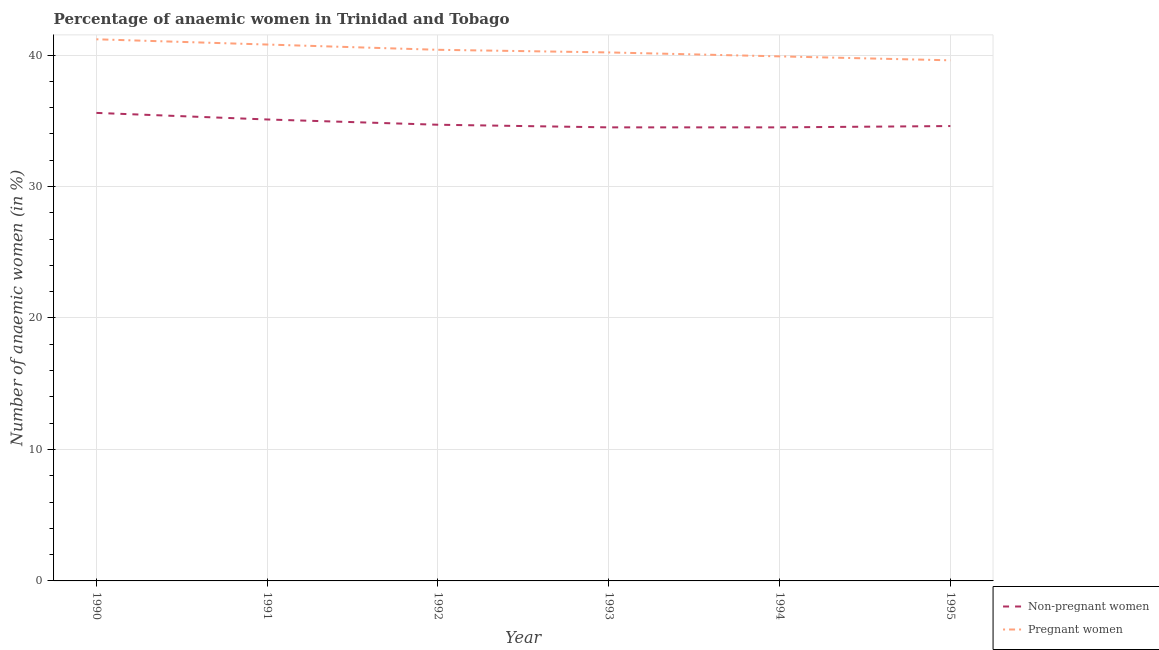Is the number of lines equal to the number of legend labels?
Offer a very short reply. Yes. What is the percentage of pregnant anaemic women in 1995?
Provide a short and direct response. 39.6. Across all years, what is the maximum percentage of pregnant anaemic women?
Give a very brief answer. 41.2. Across all years, what is the minimum percentage of pregnant anaemic women?
Provide a succinct answer. 39.6. In which year was the percentage of non-pregnant anaemic women maximum?
Offer a very short reply. 1990. In which year was the percentage of pregnant anaemic women minimum?
Your answer should be very brief. 1995. What is the total percentage of non-pregnant anaemic women in the graph?
Your answer should be compact. 209. What is the difference between the percentage of non-pregnant anaemic women in 1992 and that in 1995?
Your answer should be compact. 0.1. What is the difference between the percentage of non-pregnant anaemic women in 1993 and the percentage of pregnant anaemic women in 1994?
Ensure brevity in your answer.  -5.4. What is the average percentage of pregnant anaemic women per year?
Offer a terse response. 40.35. In the year 1990, what is the difference between the percentage of pregnant anaemic women and percentage of non-pregnant anaemic women?
Your answer should be compact. 5.6. In how many years, is the percentage of non-pregnant anaemic women greater than 16 %?
Offer a terse response. 6. What is the ratio of the percentage of non-pregnant anaemic women in 1990 to that in 1992?
Provide a short and direct response. 1.03. Is the percentage of pregnant anaemic women in 1990 less than that in 1993?
Give a very brief answer. No. What is the difference between the highest and the lowest percentage of pregnant anaemic women?
Provide a succinct answer. 1.6. Is the sum of the percentage of pregnant anaemic women in 1990 and 1994 greater than the maximum percentage of non-pregnant anaemic women across all years?
Ensure brevity in your answer.  Yes. Is the percentage of pregnant anaemic women strictly greater than the percentage of non-pregnant anaemic women over the years?
Offer a terse response. Yes. How many lines are there?
Your answer should be compact. 2. How many years are there in the graph?
Your answer should be compact. 6. What is the difference between two consecutive major ticks on the Y-axis?
Your answer should be compact. 10. Does the graph contain any zero values?
Offer a very short reply. No. Where does the legend appear in the graph?
Your answer should be compact. Bottom right. How are the legend labels stacked?
Give a very brief answer. Vertical. What is the title of the graph?
Ensure brevity in your answer.  Percentage of anaemic women in Trinidad and Tobago. Does "Highest 10% of population" appear as one of the legend labels in the graph?
Provide a short and direct response. No. What is the label or title of the X-axis?
Your response must be concise. Year. What is the label or title of the Y-axis?
Offer a terse response. Number of anaemic women (in %). What is the Number of anaemic women (in %) of Non-pregnant women in 1990?
Make the answer very short. 35.6. What is the Number of anaemic women (in %) in Pregnant women in 1990?
Offer a very short reply. 41.2. What is the Number of anaemic women (in %) in Non-pregnant women in 1991?
Provide a short and direct response. 35.1. What is the Number of anaemic women (in %) in Pregnant women in 1991?
Give a very brief answer. 40.8. What is the Number of anaemic women (in %) of Non-pregnant women in 1992?
Your answer should be very brief. 34.7. What is the Number of anaemic women (in %) in Pregnant women in 1992?
Provide a short and direct response. 40.4. What is the Number of anaemic women (in %) of Non-pregnant women in 1993?
Your response must be concise. 34.5. What is the Number of anaemic women (in %) of Pregnant women in 1993?
Your answer should be compact. 40.2. What is the Number of anaemic women (in %) of Non-pregnant women in 1994?
Your answer should be compact. 34.5. What is the Number of anaemic women (in %) in Pregnant women in 1994?
Your response must be concise. 39.9. What is the Number of anaemic women (in %) of Non-pregnant women in 1995?
Your answer should be very brief. 34.6. What is the Number of anaemic women (in %) in Pregnant women in 1995?
Give a very brief answer. 39.6. Across all years, what is the maximum Number of anaemic women (in %) of Non-pregnant women?
Give a very brief answer. 35.6. Across all years, what is the maximum Number of anaemic women (in %) of Pregnant women?
Offer a very short reply. 41.2. Across all years, what is the minimum Number of anaemic women (in %) in Non-pregnant women?
Ensure brevity in your answer.  34.5. Across all years, what is the minimum Number of anaemic women (in %) in Pregnant women?
Offer a terse response. 39.6. What is the total Number of anaemic women (in %) of Non-pregnant women in the graph?
Provide a short and direct response. 209. What is the total Number of anaemic women (in %) of Pregnant women in the graph?
Provide a succinct answer. 242.1. What is the difference between the Number of anaemic women (in %) in Pregnant women in 1990 and that in 1991?
Keep it short and to the point. 0.4. What is the difference between the Number of anaemic women (in %) of Non-pregnant women in 1990 and that in 1992?
Provide a succinct answer. 0.9. What is the difference between the Number of anaemic women (in %) of Pregnant women in 1990 and that in 1992?
Provide a succinct answer. 0.8. What is the difference between the Number of anaemic women (in %) of Non-pregnant women in 1990 and that in 1993?
Your response must be concise. 1.1. What is the difference between the Number of anaemic women (in %) of Pregnant women in 1990 and that in 1993?
Offer a very short reply. 1. What is the difference between the Number of anaemic women (in %) in Pregnant women in 1990 and that in 1994?
Your response must be concise. 1.3. What is the difference between the Number of anaemic women (in %) of Non-pregnant women in 1990 and that in 1995?
Give a very brief answer. 1. What is the difference between the Number of anaemic women (in %) in Pregnant women in 1991 and that in 1992?
Ensure brevity in your answer.  0.4. What is the difference between the Number of anaemic women (in %) in Non-pregnant women in 1991 and that in 1993?
Keep it short and to the point. 0.6. What is the difference between the Number of anaemic women (in %) in Non-pregnant women in 1991 and that in 1994?
Your answer should be compact. 0.6. What is the difference between the Number of anaemic women (in %) in Non-pregnant women in 1991 and that in 1995?
Give a very brief answer. 0.5. What is the difference between the Number of anaemic women (in %) of Pregnant women in 1991 and that in 1995?
Your answer should be very brief. 1.2. What is the difference between the Number of anaemic women (in %) in Non-pregnant women in 1992 and that in 1993?
Offer a very short reply. 0.2. What is the difference between the Number of anaemic women (in %) of Non-pregnant women in 1992 and that in 1994?
Your answer should be very brief. 0.2. What is the difference between the Number of anaemic women (in %) of Pregnant women in 1992 and that in 1994?
Your response must be concise. 0.5. What is the difference between the Number of anaemic women (in %) in Non-pregnant women in 1993 and that in 1994?
Provide a short and direct response. 0. What is the difference between the Number of anaemic women (in %) of Pregnant women in 1993 and that in 1995?
Make the answer very short. 0.6. What is the difference between the Number of anaemic women (in %) in Non-pregnant women in 1994 and that in 1995?
Offer a terse response. -0.1. What is the difference between the Number of anaemic women (in %) in Non-pregnant women in 1990 and the Number of anaemic women (in %) in Pregnant women in 1991?
Offer a very short reply. -5.2. What is the difference between the Number of anaemic women (in %) of Non-pregnant women in 1990 and the Number of anaemic women (in %) of Pregnant women in 1992?
Your response must be concise. -4.8. What is the difference between the Number of anaemic women (in %) in Non-pregnant women in 1991 and the Number of anaemic women (in %) in Pregnant women in 1994?
Provide a short and direct response. -4.8. What is the difference between the Number of anaemic women (in %) in Non-pregnant women in 1993 and the Number of anaemic women (in %) in Pregnant women in 1995?
Provide a short and direct response. -5.1. What is the average Number of anaemic women (in %) of Non-pregnant women per year?
Ensure brevity in your answer.  34.83. What is the average Number of anaemic women (in %) of Pregnant women per year?
Your answer should be compact. 40.35. In the year 1990, what is the difference between the Number of anaemic women (in %) in Non-pregnant women and Number of anaemic women (in %) in Pregnant women?
Keep it short and to the point. -5.6. In the year 1992, what is the difference between the Number of anaemic women (in %) in Non-pregnant women and Number of anaemic women (in %) in Pregnant women?
Provide a short and direct response. -5.7. In the year 1994, what is the difference between the Number of anaemic women (in %) in Non-pregnant women and Number of anaemic women (in %) in Pregnant women?
Your response must be concise. -5.4. What is the ratio of the Number of anaemic women (in %) in Non-pregnant women in 1990 to that in 1991?
Your response must be concise. 1.01. What is the ratio of the Number of anaemic women (in %) in Pregnant women in 1990 to that in 1991?
Offer a terse response. 1.01. What is the ratio of the Number of anaemic women (in %) of Non-pregnant women in 1990 to that in 1992?
Provide a succinct answer. 1.03. What is the ratio of the Number of anaemic women (in %) of Pregnant women in 1990 to that in 1992?
Your response must be concise. 1.02. What is the ratio of the Number of anaemic women (in %) of Non-pregnant women in 1990 to that in 1993?
Your response must be concise. 1.03. What is the ratio of the Number of anaemic women (in %) in Pregnant women in 1990 to that in 1993?
Provide a succinct answer. 1.02. What is the ratio of the Number of anaemic women (in %) in Non-pregnant women in 1990 to that in 1994?
Make the answer very short. 1.03. What is the ratio of the Number of anaemic women (in %) of Pregnant women in 1990 to that in 1994?
Keep it short and to the point. 1.03. What is the ratio of the Number of anaemic women (in %) in Non-pregnant women in 1990 to that in 1995?
Your response must be concise. 1.03. What is the ratio of the Number of anaemic women (in %) in Pregnant women in 1990 to that in 1995?
Provide a succinct answer. 1.04. What is the ratio of the Number of anaemic women (in %) of Non-pregnant women in 1991 to that in 1992?
Offer a very short reply. 1.01. What is the ratio of the Number of anaemic women (in %) of Pregnant women in 1991 to that in 1992?
Your answer should be compact. 1.01. What is the ratio of the Number of anaemic women (in %) of Non-pregnant women in 1991 to that in 1993?
Offer a very short reply. 1.02. What is the ratio of the Number of anaemic women (in %) of Pregnant women in 1991 to that in 1993?
Provide a short and direct response. 1.01. What is the ratio of the Number of anaemic women (in %) of Non-pregnant women in 1991 to that in 1994?
Offer a very short reply. 1.02. What is the ratio of the Number of anaemic women (in %) in Pregnant women in 1991 to that in 1994?
Provide a short and direct response. 1.02. What is the ratio of the Number of anaemic women (in %) of Non-pregnant women in 1991 to that in 1995?
Ensure brevity in your answer.  1.01. What is the ratio of the Number of anaemic women (in %) in Pregnant women in 1991 to that in 1995?
Your response must be concise. 1.03. What is the ratio of the Number of anaemic women (in %) of Non-pregnant women in 1992 to that in 1993?
Make the answer very short. 1.01. What is the ratio of the Number of anaemic women (in %) of Non-pregnant women in 1992 to that in 1994?
Offer a terse response. 1.01. What is the ratio of the Number of anaemic women (in %) of Pregnant women in 1992 to that in 1994?
Your answer should be compact. 1.01. What is the ratio of the Number of anaemic women (in %) in Non-pregnant women in 1992 to that in 1995?
Offer a very short reply. 1. What is the ratio of the Number of anaemic women (in %) of Pregnant women in 1992 to that in 1995?
Offer a very short reply. 1.02. What is the ratio of the Number of anaemic women (in %) in Pregnant women in 1993 to that in 1994?
Make the answer very short. 1.01. What is the ratio of the Number of anaemic women (in %) in Non-pregnant women in 1993 to that in 1995?
Ensure brevity in your answer.  1. What is the ratio of the Number of anaemic women (in %) of Pregnant women in 1993 to that in 1995?
Offer a very short reply. 1.02. What is the ratio of the Number of anaemic women (in %) in Pregnant women in 1994 to that in 1995?
Offer a terse response. 1.01. What is the difference between the highest and the second highest Number of anaemic women (in %) in Non-pregnant women?
Your answer should be compact. 0.5. What is the difference between the highest and the lowest Number of anaemic women (in %) of Pregnant women?
Your answer should be very brief. 1.6. 